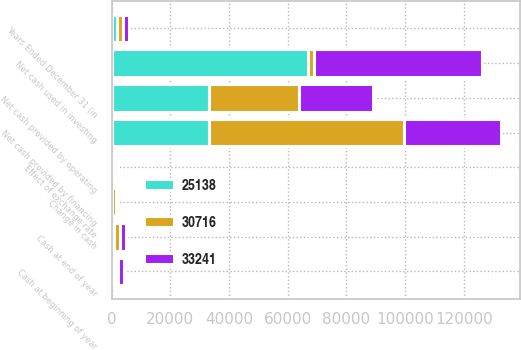<chart> <loc_0><loc_0><loc_500><loc_500><stacked_bar_chart><ecel><fcel>Years Ended December 31 (in<fcel>Net cash provided by operating<fcel>Net cash used in investing<fcel>Net cash provided by financing<fcel>Effect of exchange rate<fcel>Change in cash<fcel>Cash at beginning of year<fcel>Cash at end of year<nl><fcel>33241<fcel>2005<fcel>25138<fcel>57321<fcel>32999<fcel>928<fcel>112<fcel>2009<fcel>1897<nl><fcel>30716<fcel>2004<fcel>30716<fcel>2004<fcel>66494<fcel>992<fcel>1087<fcel>922<fcel>2009<nl><fcel>25138<fcel>2003<fcel>33241<fcel>66904<fcel>33070<fcel>350<fcel>243<fcel>1165<fcel>922<nl></chart> 